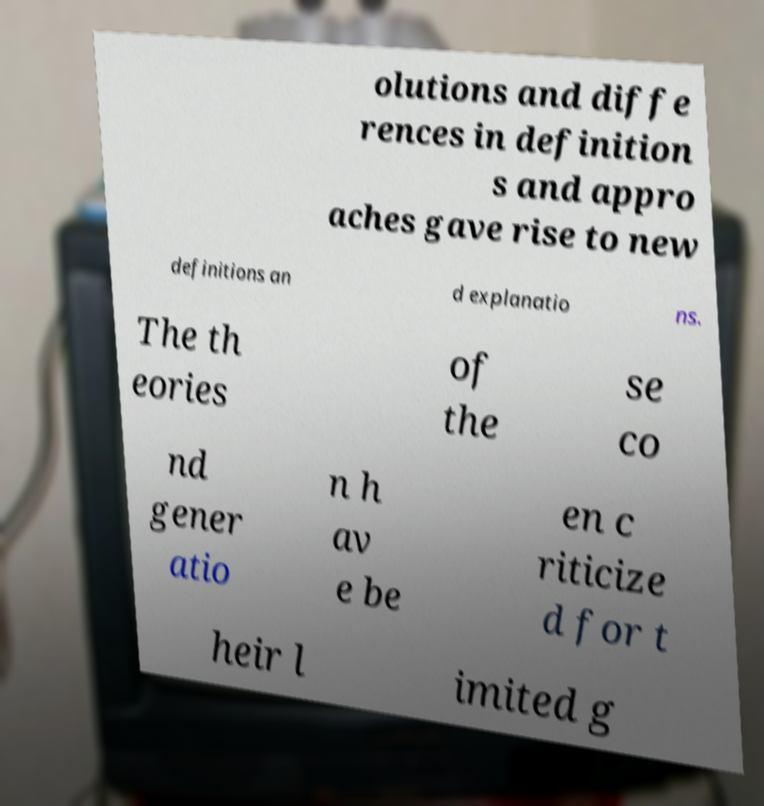What messages or text are displayed in this image? I need them in a readable, typed format. olutions and diffe rences in definition s and appro aches gave rise to new definitions an d explanatio ns. The th eories of the se co nd gener atio n h av e be en c riticize d for t heir l imited g 